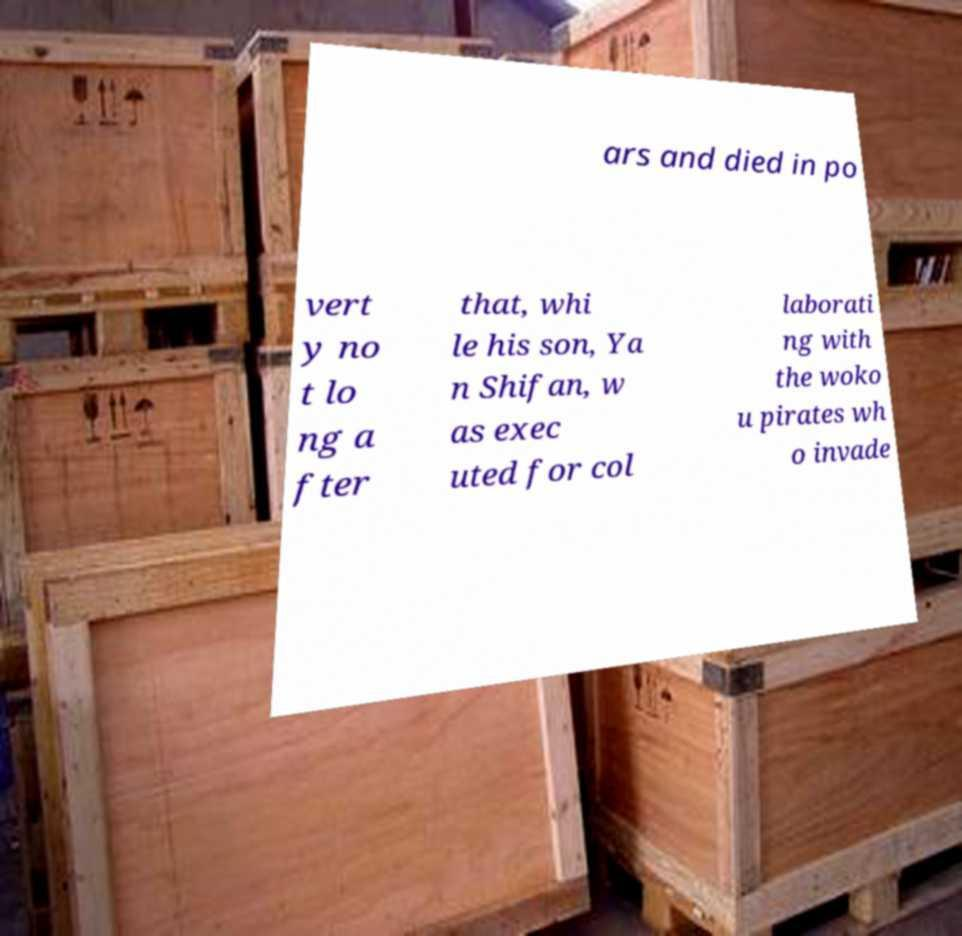Please identify and transcribe the text found in this image. ars and died in po vert y no t lo ng a fter that, whi le his son, Ya n Shifan, w as exec uted for col laborati ng with the woko u pirates wh o invade 